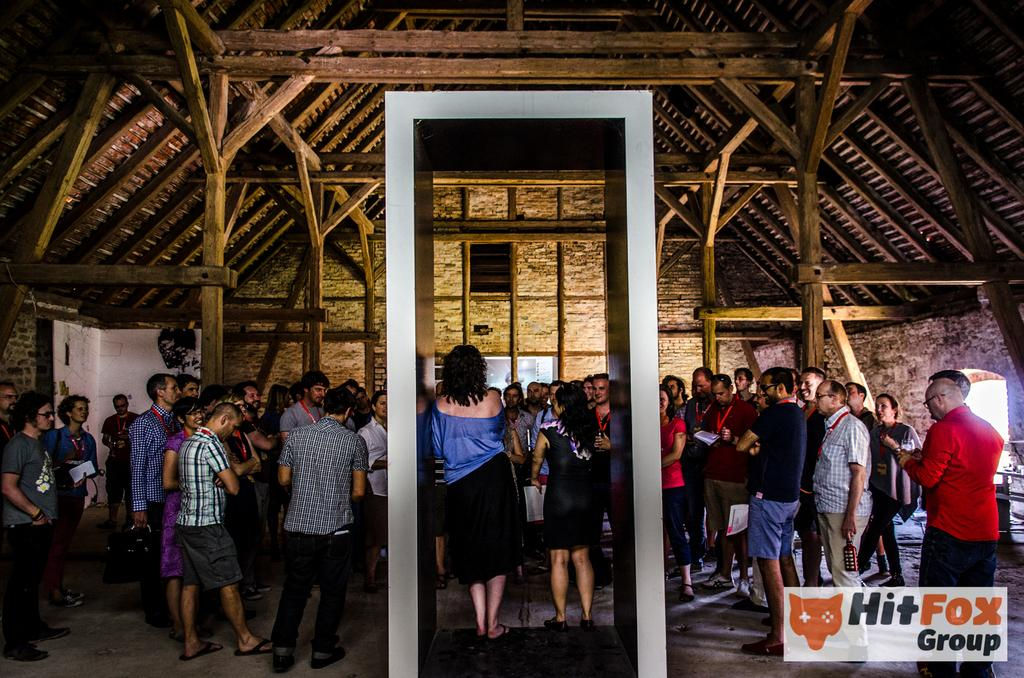How many people are in the image? There is a group of people in the image. What are the people in the image doing? The people are standing. Is there any text or marking visible in the image? Yes, there is a watermark at the bottom right of the image. What type of lamp can be seen in the image? There is no lamp present in the image. What kind of boundary is visible in the image? There is no boundary visible in the image. 